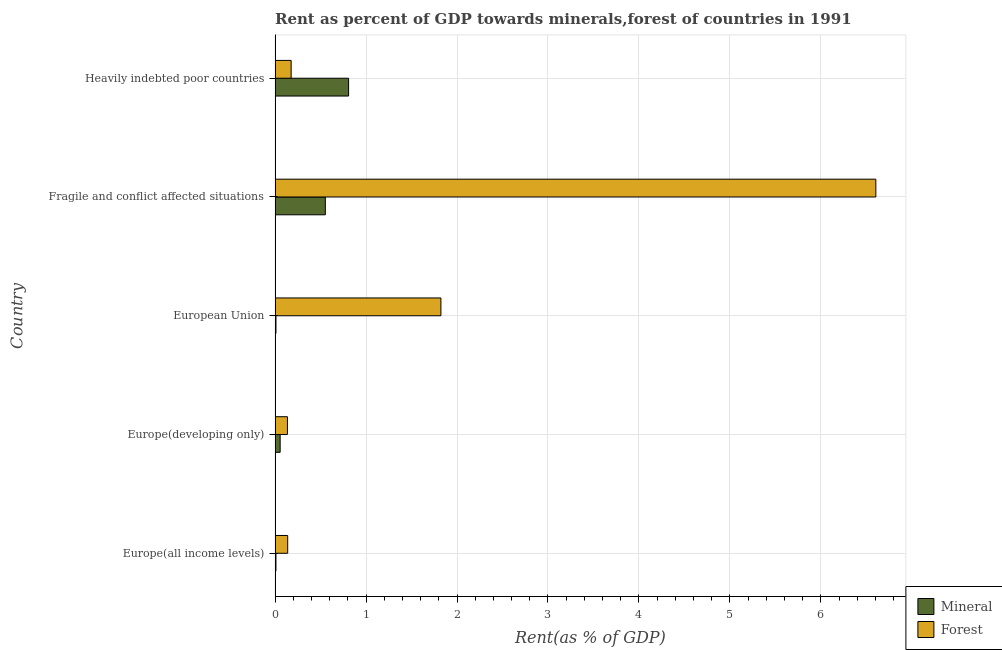How many different coloured bars are there?
Provide a short and direct response. 2. Are the number of bars per tick equal to the number of legend labels?
Offer a very short reply. Yes. Are the number of bars on each tick of the Y-axis equal?
Provide a succinct answer. Yes. How many bars are there on the 2nd tick from the top?
Give a very brief answer. 2. What is the label of the 3rd group of bars from the top?
Your answer should be very brief. European Union. What is the forest rent in Heavily indebted poor countries?
Offer a very short reply. 0.18. Across all countries, what is the maximum mineral rent?
Ensure brevity in your answer.  0.81. Across all countries, what is the minimum mineral rent?
Offer a terse response. 0.01. In which country was the mineral rent maximum?
Give a very brief answer. Heavily indebted poor countries. In which country was the mineral rent minimum?
Offer a very short reply. Europe(all income levels). What is the total forest rent in the graph?
Provide a succinct answer. 8.88. What is the difference between the forest rent in Europe(developing only) and that in Heavily indebted poor countries?
Your response must be concise. -0.04. What is the difference between the forest rent in Europe(all income levels) and the mineral rent in Heavily indebted poor countries?
Your response must be concise. -0.67. What is the average mineral rent per country?
Your response must be concise. 0.29. What is the difference between the forest rent and mineral rent in Fragile and conflict affected situations?
Make the answer very short. 6.05. In how many countries, is the mineral rent greater than 0.6000000000000001 %?
Ensure brevity in your answer.  1. What is the ratio of the forest rent in Europe(all income levels) to that in Heavily indebted poor countries?
Your answer should be very brief. 0.79. Is the difference between the forest rent in Europe(all income levels) and European Union greater than the difference between the mineral rent in Europe(all income levels) and European Union?
Your response must be concise. No. What is the difference between the highest and the second highest forest rent?
Offer a very short reply. 4.78. What is the difference between the highest and the lowest forest rent?
Ensure brevity in your answer.  6.47. Is the sum of the forest rent in Europe(all income levels) and European Union greater than the maximum mineral rent across all countries?
Provide a short and direct response. Yes. What does the 1st bar from the top in European Union represents?
Your response must be concise. Forest. What does the 2nd bar from the bottom in European Union represents?
Make the answer very short. Forest. How many countries are there in the graph?
Provide a short and direct response. 5. Are the values on the major ticks of X-axis written in scientific E-notation?
Keep it short and to the point. No. Does the graph contain any zero values?
Give a very brief answer. No. How are the legend labels stacked?
Your response must be concise. Vertical. What is the title of the graph?
Give a very brief answer. Rent as percent of GDP towards minerals,forest of countries in 1991. What is the label or title of the X-axis?
Your answer should be compact. Rent(as % of GDP). What is the Rent(as % of GDP) of Mineral in Europe(all income levels)?
Provide a succinct answer. 0.01. What is the Rent(as % of GDP) in Forest in Europe(all income levels)?
Keep it short and to the point. 0.14. What is the Rent(as % of GDP) of Mineral in Europe(developing only)?
Your answer should be very brief. 0.06. What is the Rent(as % of GDP) of Forest in Europe(developing only)?
Your answer should be very brief. 0.14. What is the Rent(as % of GDP) in Mineral in European Union?
Offer a very short reply. 0.01. What is the Rent(as % of GDP) of Forest in European Union?
Offer a terse response. 1.82. What is the Rent(as % of GDP) in Mineral in Fragile and conflict affected situations?
Provide a succinct answer. 0.55. What is the Rent(as % of GDP) of Forest in Fragile and conflict affected situations?
Your response must be concise. 6.6. What is the Rent(as % of GDP) in Mineral in Heavily indebted poor countries?
Your answer should be compact. 0.81. What is the Rent(as % of GDP) of Forest in Heavily indebted poor countries?
Your response must be concise. 0.18. Across all countries, what is the maximum Rent(as % of GDP) of Mineral?
Offer a very short reply. 0.81. Across all countries, what is the maximum Rent(as % of GDP) of Forest?
Keep it short and to the point. 6.6. Across all countries, what is the minimum Rent(as % of GDP) in Mineral?
Ensure brevity in your answer.  0.01. Across all countries, what is the minimum Rent(as % of GDP) of Forest?
Ensure brevity in your answer.  0.14. What is the total Rent(as % of GDP) in Mineral in the graph?
Your answer should be compact. 1.44. What is the total Rent(as % of GDP) in Forest in the graph?
Your response must be concise. 8.88. What is the difference between the Rent(as % of GDP) in Mineral in Europe(all income levels) and that in Europe(developing only)?
Ensure brevity in your answer.  -0.05. What is the difference between the Rent(as % of GDP) of Forest in Europe(all income levels) and that in Europe(developing only)?
Offer a very short reply. 0. What is the difference between the Rent(as % of GDP) of Mineral in Europe(all income levels) and that in European Union?
Give a very brief answer. -0. What is the difference between the Rent(as % of GDP) of Forest in Europe(all income levels) and that in European Union?
Offer a terse response. -1.68. What is the difference between the Rent(as % of GDP) in Mineral in Europe(all income levels) and that in Fragile and conflict affected situations?
Ensure brevity in your answer.  -0.54. What is the difference between the Rent(as % of GDP) in Forest in Europe(all income levels) and that in Fragile and conflict affected situations?
Provide a succinct answer. -6.47. What is the difference between the Rent(as % of GDP) of Mineral in Europe(all income levels) and that in Heavily indebted poor countries?
Your answer should be very brief. -0.8. What is the difference between the Rent(as % of GDP) of Forest in Europe(all income levels) and that in Heavily indebted poor countries?
Keep it short and to the point. -0.04. What is the difference between the Rent(as % of GDP) in Mineral in Europe(developing only) and that in European Union?
Offer a very short reply. 0.05. What is the difference between the Rent(as % of GDP) of Forest in Europe(developing only) and that in European Union?
Provide a short and direct response. -1.69. What is the difference between the Rent(as % of GDP) of Mineral in Europe(developing only) and that in Fragile and conflict affected situations?
Provide a short and direct response. -0.5. What is the difference between the Rent(as % of GDP) of Forest in Europe(developing only) and that in Fragile and conflict affected situations?
Offer a very short reply. -6.47. What is the difference between the Rent(as % of GDP) of Mineral in Europe(developing only) and that in Heavily indebted poor countries?
Make the answer very short. -0.75. What is the difference between the Rent(as % of GDP) of Forest in Europe(developing only) and that in Heavily indebted poor countries?
Provide a short and direct response. -0.04. What is the difference between the Rent(as % of GDP) of Mineral in European Union and that in Fragile and conflict affected situations?
Your answer should be very brief. -0.54. What is the difference between the Rent(as % of GDP) of Forest in European Union and that in Fragile and conflict affected situations?
Offer a very short reply. -4.78. What is the difference between the Rent(as % of GDP) of Mineral in European Union and that in Heavily indebted poor countries?
Your answer should be compact. -0.8. What is the difference between the Rent(as % of GDP) in Forest in European Union and that in Heavily indebted poor countries?
Your answer should be compact. 1.65. What is the difference between the Rent(as % of GDP) in Mineral in Fragile and conflict affected situations and that in Heavily indebted poor countries?
Your answer should be very brief. -0.26. What is the difference between the Rent(as % of GDP) in Forest in Fragile and conflict affected situations and that in Heavily indebted poor countries?
Your answer should be compact. 6.43. What is the difference between the Rent(as % of GDP) in Mineral in Europe(all income levels) and the Rent(as % of GDP) in Forest in Europe(developing only)?
Your answer should be compact. -0.13. What is the difference between the Rent(as % of GDP) in Mineral in Europe(all income levels) and the Rent(as % of GDP) in Forest in European Union?
Offer a very short reply. -1.81. What is the difference between the Rent(as % of GDP) in Mineral in Europe(all income levels) and the Rent(as % of GDP) in Forest in Fragile and conflict affected situations?
Offer a terse response. -6.59. What is the difference between the Rent(as % of GDP) of Mineral in Europe(all income levels) and the Rent(as % of GDP) of Forest in Heavily indebted poor countries?
Your answer should be compact. -0.17. What is the difference between the Rent(as % of GDP) of Mineral in Europe(developing only) and the Rent(as % of GDP) of Forest in European Union?
Make the answer very short. -1.77. What is the difference between the Rent(as % of GDP) of Mineral in Europe(developing only) and the Rent(as % of GDP) of Forest in Fragile and conflict affected situations?
Make the answer very short. -6.55. What is the difference between the Rent(as % of GDP) of Mineral in Europe(developing only) and the Rent(as % of GDP) of Forest in Heavily indebted poor countries?
Provide a succinct answer. -0.12. What is the difference between the Rent(as % of GDP) of Mineral in European Union and the Rent(as % of GDP) of Forest in Fragile and conflict affected situations?
Offer a very short reply. -6.59. What is the difference between the Rent(as % of GDP) of Mineral in European Union and the Rent(as % of GDP) of Forest in Heavily indebted poor countries?
Give a very brief answer. -0.17. What is the difference between the Rent(as % of GDP) in Mineral in Fragile and conflict affected situations and the Rent(as % of GDP) in Forest in Heavily indebted poor countries?
Provide a short and direct response. 0.38. What is the average Rent(as % of GDP) in Mineral per country?
Provide a succinct answer. 0.29. What is the average Rent(as % of GDP) of Forest per country?
Ensure brevity in your answer.  1.78. What is the difference between the Rent(as % of GDP) in Mineral and Rent(as % of GDP) in Forest in Europe(all income levels)?
Your response must be concise. -0.13. What is the difference between the Rent(as % of GDP) in Mineral and Rent(as % of GDP) in Forest in Europe(developing only)?
Ensure brevity in your answer.  -0.08. What is the difference between the Rent(as % of GDP) of Mineral and Rent(as % of GDP) of Forest in European Union?
Your response must be concise. -1.81. What is the difference between the Rent(as % of GDP) of Mineral and Rent(as % of GDP) of Forest in Fragile and conflict affected situations?
Your response must be concise. -6.05. What is the difference between the Rent(as % of GDP) in Mineral and Rent(as % of GDP) in Forest in Heavily indebted poor countries?
Offer a very short reply. 0.63. What is the ratio of the Rent(as % of GDP) of Mineral in Europe(all income levels) to that in Europe(developing only)?
Ensure brevity in your answer.  0.17. What is the ratio of the Rent(as % of GDP) of Forest in Europe(all income levels) to that in Europe(developing only)?
Keep it short and to the point. 1.02. What is the ratio of the Rent(as % of GDP) of Mineral in Europe(all income levels) to that in European Union?
Provide a succinct answer. 0.98. What is the ratio of the Rent(as % of GDP) of Forest in Europe(all income levels) to that in European Union?
Your answer should be very brief. 0.08. What is the ratio of the Rent(as % of GDP) in Mineral in Europe(all income levels) to that in Fragile and conflict affected situations?
Provide a succinct answer. 0.02. What is the ratio of the Rent(as % of GDP) of Forest in Europe(all income levels) to that in Fragile and conflict affected situations?
Make the answer very short. 0.02. What is the ratio of the Rent(as % of GDP) of Mineral in Europe(all income levels) to that in Heavily indebted poor countries?
Give a very brief answer. 0.01. What is the ratio of the Rent(as % of GDP) of Forest in Europe(all income levels) to that in Heavily indebted poor countries?
Keep it short and to the point. 0.79. What is the ratio of the Rent(as % of GDP) in Mineral in Europe(developing only) to that in European Union?
Your response must be concise. 5.69. What is the ratio of the Rent(as % of GDP) of Forest in Europe(developing only) to that in European Union?
Offer a terse response. 0.07. What is the ratio of the Rent(as % of GDP) in Mineral in Europe(developing only) to that in Fragile and conflict affected situations?
Make the answer very short. 0.1. What is the ratio of the Rent(as % of GDP) in Forest in Europe(developing only) to that in Fragile and conflict affected situations?
Provide a succinct answer. 0.02. What is the ratio of the Rent(as % of GDP) in Mineral in Europe(developing only) to that in Heavily indebted poor countries?
Your answer should be very brief. 0.07. What is the ratio of the Rent(as % of GDP) of Forest in Europe(developing only) to that in Heavily indebted poor countries?
Provide a succinct answer. 0.77. What is the ratio of the Rent(as % of GDP) of Mineral in European Union to that in Fragile and conflict affected situations?
Ensure brevity in your answer.  0.02. What is the ratio of the Rent(as % of GDP) in Forest in European Union to that in Fragile and conflict affected situations?
Provide a short and direct response. 0.28. What is the ratio of the Rent(as % of GDP) of Mineral in European Union to that in Heavily indebted poor countries?
Make the answer very short. 0.01. What is the ratio of the Rent(as % of GDP) in Forest in European Union to that in Heavily indebted poor countries?
Provide a short and direct response. 10.32. What is the ratio of the Rent(as % of GDP) in Mineral in Fragile and conflict affected situations to that in Heavily indebted poor countries?
Provide a short and direct response. 0.68. What is the ratio of the Rent(as % of GDP) in Forest in Fragile and conflict affected situations to that in Heavily indebted poor countries?
Give a very brief answer. 37.41. What is the difference between the highest and the second highest Rent(as % of GDP) of Mineral?
Your answer should be very brief. 0.26. What is the difference between the highest and the second highest Rent(as % of GDP) of Forest?
Make the answer very short. 4.78. What is the difference between the highest and the lowest Rent(as % of GDP) in Mineral?
Your response must be concise. 0.8. What is the difference between the highest and the lowest Rent(as % of GDP) of Forest?
Your answer should be compact. 6.47. 